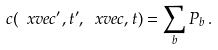Convert formula to latex. <formula><loc_0><loc_0><loc_500><loc_500>c ( \ x v e c ^ { \prime } , t ^ { \prime } , \ x v e c , t ) = \sum _ { b } P _ { b } \, .</formula> 